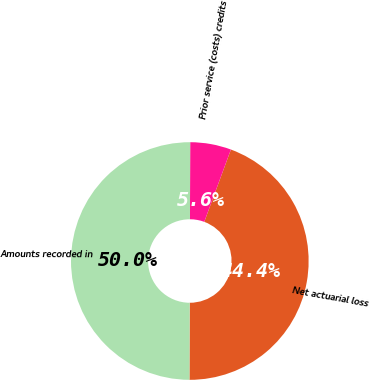Convert chart to OTSL. <chart><loc_0><loc_0><loc_500><loc_500><pie_chart><fcel>Net actuarial loss<fcel>Prior service (costs) credits<fcel>Amounts recorded in<nl><fcel>44.43%<fcel>5.57%<fcel>50.0%<nl></chart> 